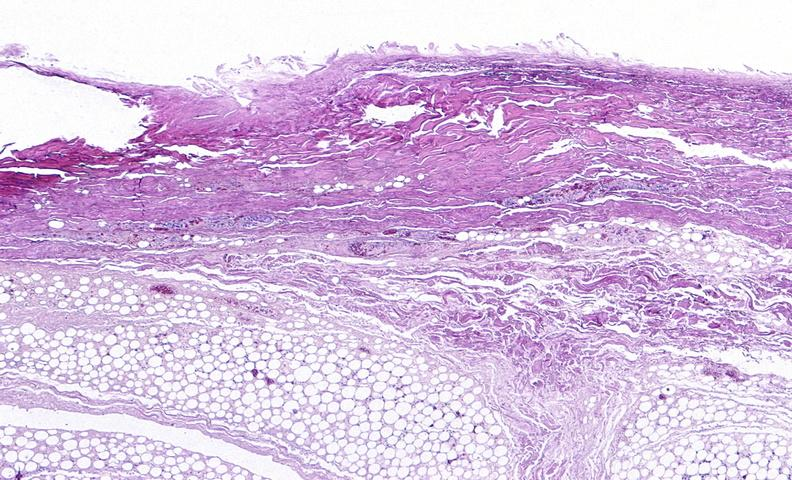does this image show panniculitis and fascitis?
Answer the question using a single word or phrase. Yes 